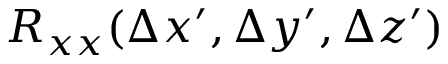<formula> <loc_0><loc_0><loc_500><loc_500>R _ { x x } ( \Delta x ^ { \prime } , \Delta y ^ { \prime } , \Delta z ^ { \prime } )</formula> 